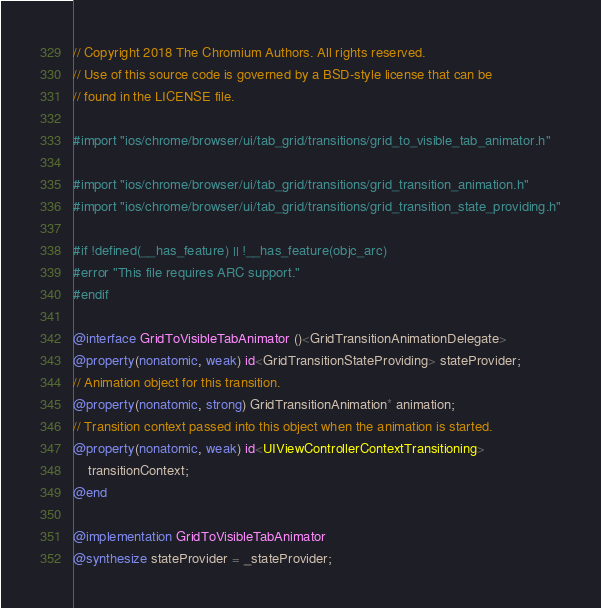Convert code to text. <code><loc_0><loc_0><loc_500><loc_500><_ObjectiveC_>// Copyright 2018 The Chromium Authors. All rights reserved.
// Use of this source code is governed by a BSD-style license that can be
// found in the LICENSE file.

#import "ios/chrome/browser/ui/tab_grid/transitions/grid_to_visible_tab_animator.h"

#import "ios/chrome/browser/ui/tab_grid/transitions/grid_transition_animation.h"
#import "ios/chrome/browser/ui/tab_grid/transitions/grid_transition_state_providing.h"

#if !defined(__has_feature) || !__has_feature(objc_arc)
#error "This file requires ARC support."
#endif

@interface GridToVisibleTabAnimator ()<GridTransitionAnimationDelegate>
@property(nonatomic, weak) id<GridTransitionStateProviding> stateProvider;
// Animation object for this transition.
@property(nonatomic, strong) GridTransitionAnimation* animation;
// Transition context passed into this object when the animation is started.
@property(nonatomic, weak) id<UIViewControllerContextTransitioning>
    transitionContext;
@end

@implementation GridToVisibleTabAnimator
@synthesize stateProvider = _stateProvider;</code> 